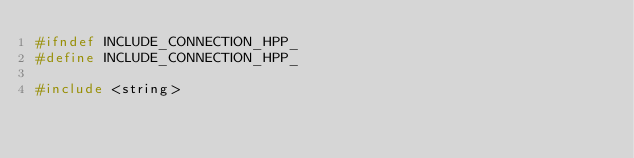<code> <loc_0><loc_0><loc_500><loc_500><_C++_>#ifndef INCLUDE_CONNECTION_HPP_
#define INCLUDE_CONNECTION_HPP_

#include <string>
</code> 